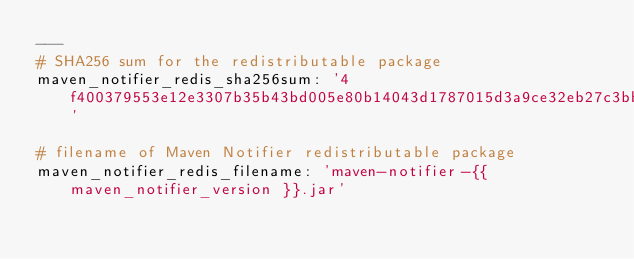<code> <loc_0><loc_0><loc_500><loc_500><_YAML_>---
# SHA256 sum for the redistributable package
maven_notifier_redis_sha256sum: '4f400379553e12e3307b35b43bd005e80b14043d1787015d3a9ce32eb27c3bb3'

# filename of Maven Notifier redistributable package
maven_notifier_redis_filename: 'maven-notifier-{{ maven_notifier_version }}.jar'
</code> 